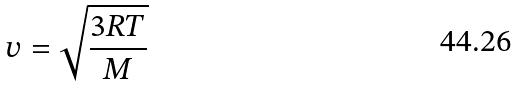Convert formula to latex. <formula><loc_0><loc_0><loc_500><loc_500>v = \sqrt { \frac { 3 R T } { M } }</formula> 